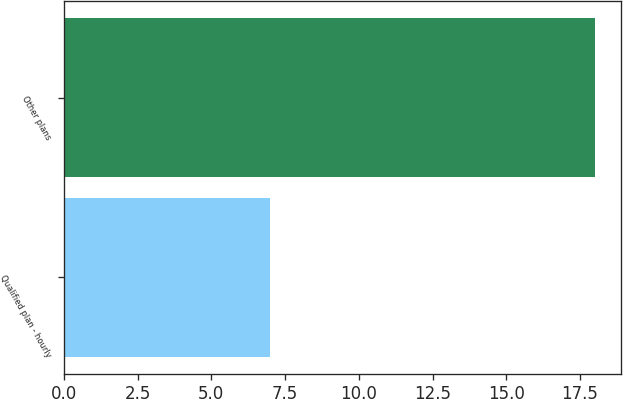<chart> <loc_0><loc_0><loc_500><loc_500><bar_chart><fcel>Qualified plan - hourly<fcel>Other plans<nl><fcel>7<fcel>18<nl></chart> 